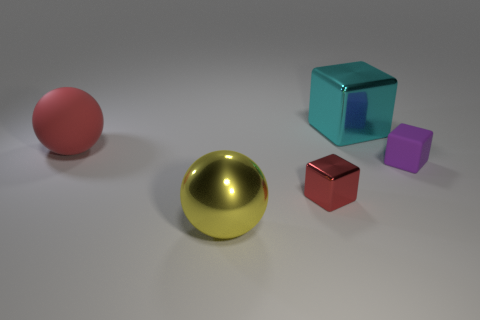Add 2 big cyan blocks. How many objects exist? 7 Subtract all spheres. How many objects are left? 3 Add 1 tiny matte cubes. How many tiny matte cubes are left? 2 Add 3 large yellow metal objects. How many large yellow metal objects exist? 4 Subtract 1 red cubes. How many objects are left? 4 Subtract all large matte balls. Subtract all purple cubes. How many objects are left? 3 